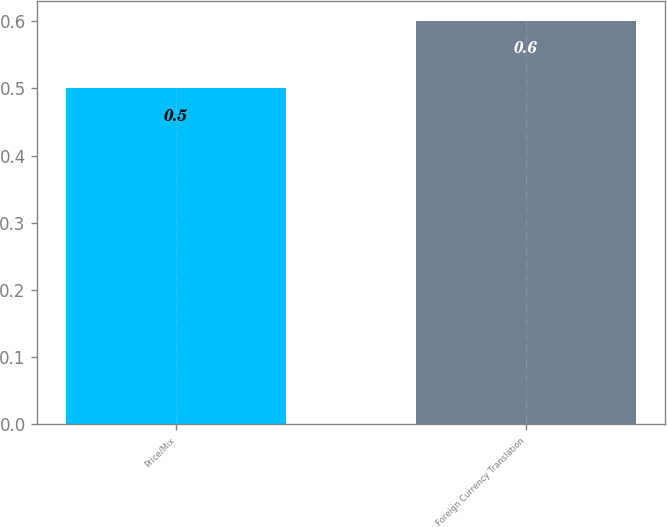Convert chart to OTSL. <chart><loc_0><loc_0><loc_500><loc_500><bar_chart><fcel>Price/Mix<fcel>Foreign Currency Translation<nl><fcel>0.5<fcel>0.6<nl></chart> 